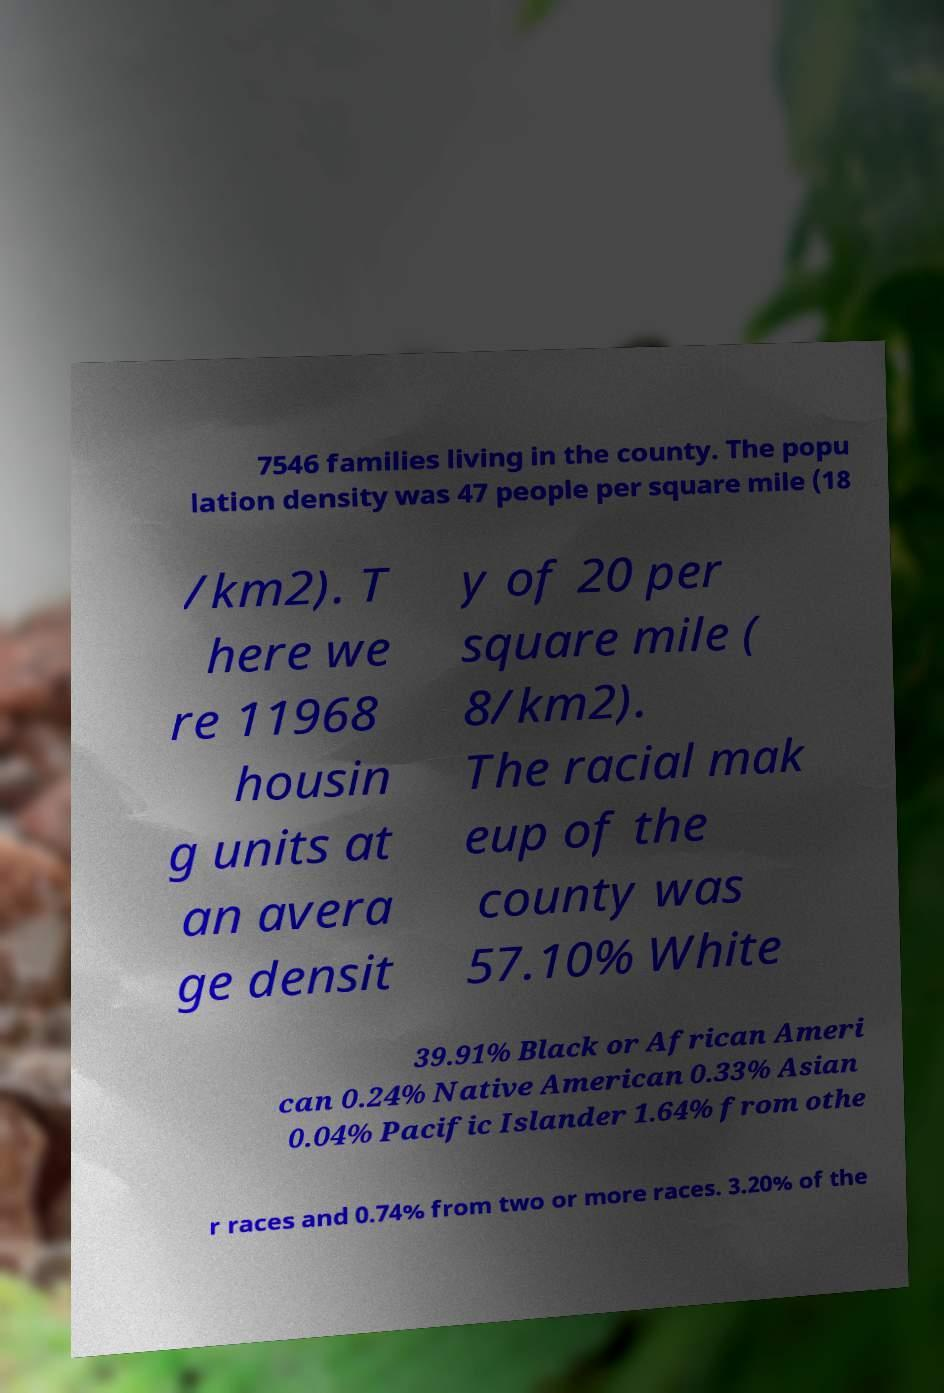I need the written content from this picture converted into text. Can you do that? 7546 families living in the county. The popu lation density was 47 people per square mile (18 /km2). T here we re 11968 housin g units at an avera ge densit y of 20 per square mile ( 8/km2). The racial mak eup of the county was 57.10% White 39.91% Black or African Ameri can 0.24% Native American 0.33% Asian 0.04% Pacific Islander 1.64% from othe r races and 0.74% from two or more races. 3.20% of the 